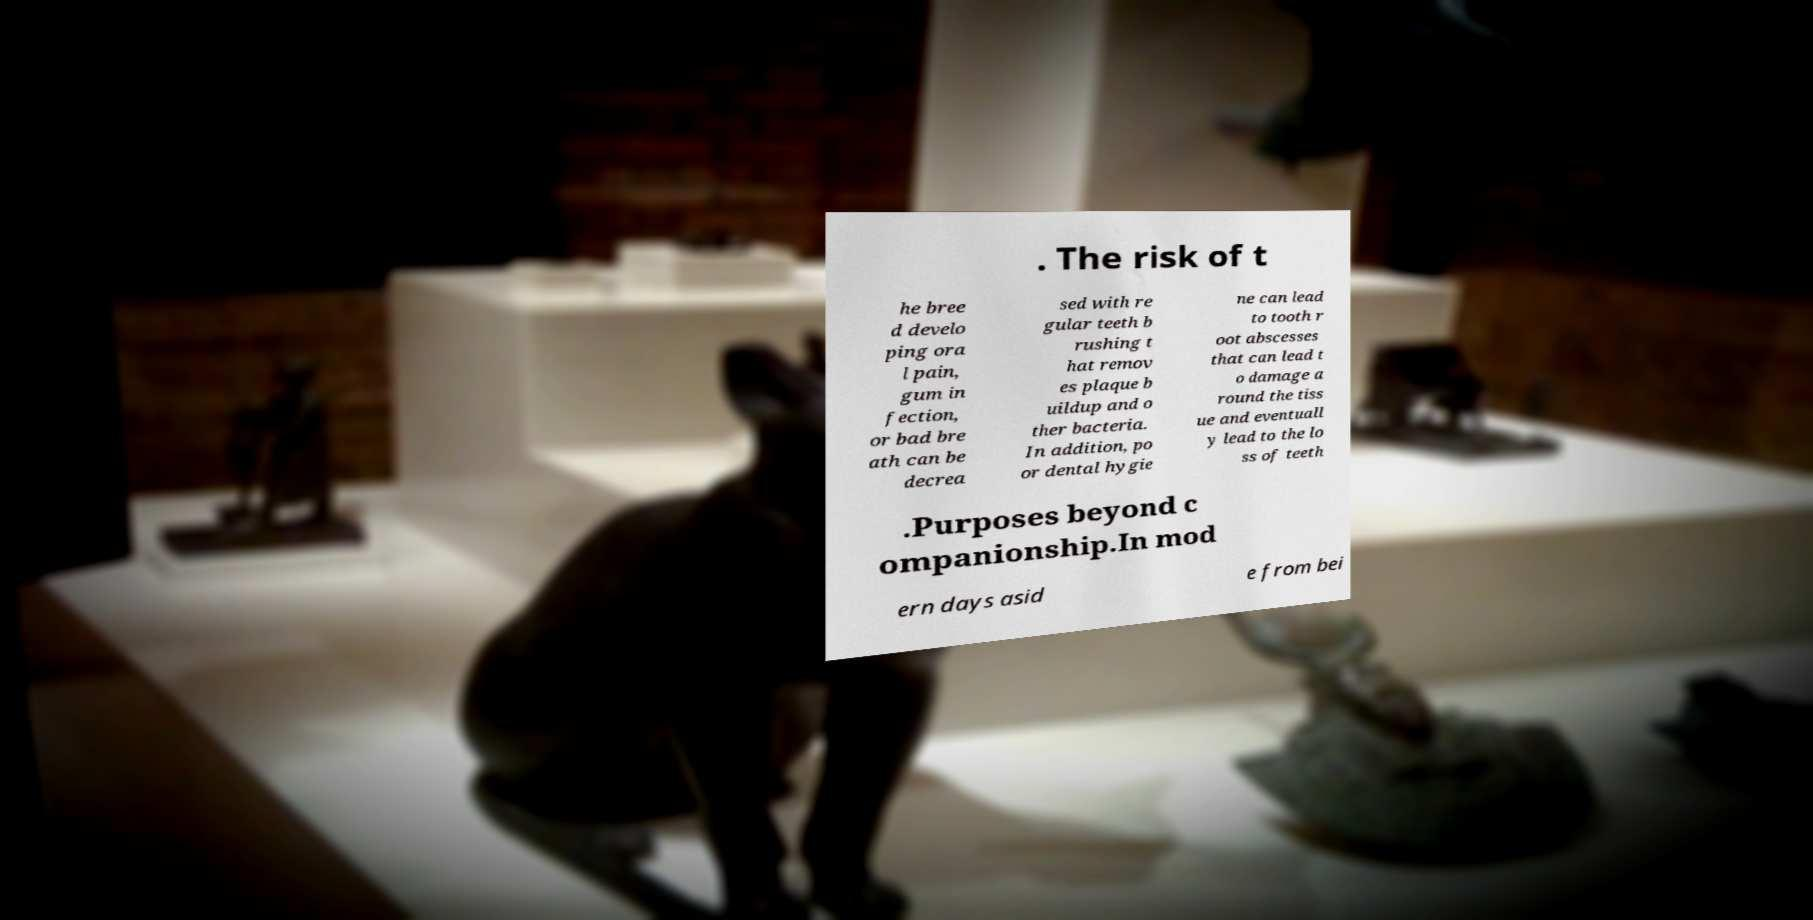Could you extract and type out the text from this image? . The risk of t he bree d develo ping ora l pain, gum in fection, or bad bre ath can be decrea sed with re gular teeth b rushing t hat remov es plaque b uildup and o ther bacteria. In addition, po or dental hygie ne can lead to tooth r oot abscesses that can lead t o damage a round the tiss ue and eventuall y lead to the lo ss of teeth .Purposes beyond c ompanionship.In mod ern days asid e from bei 